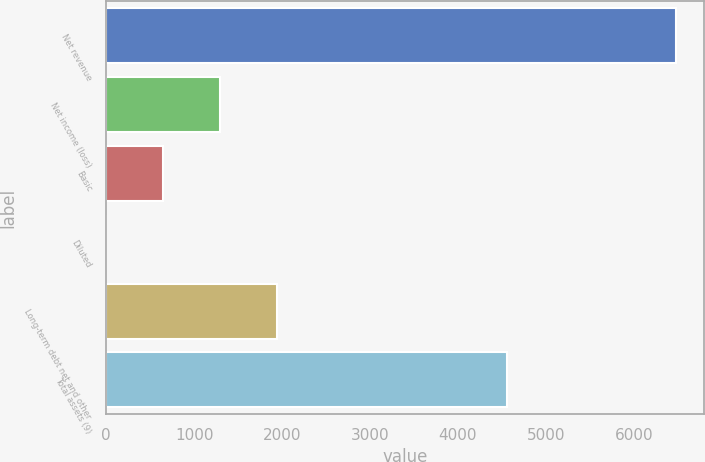Convert chart to OTSL. <chart><loc_0><loc_0><loc_500><loc_500><bar_chart><fcel>Net revenue<fcel>Net income (loss)<fcel>Basic<fcel>Diluted<fcel>Long-term debt net and other<fcel>Total assets (9)<nl><fcel>6475<fcel>1295.26<fcel>647.79<fcel>0.32<fcel>1942.73<fcel>4556<nl></chart> 